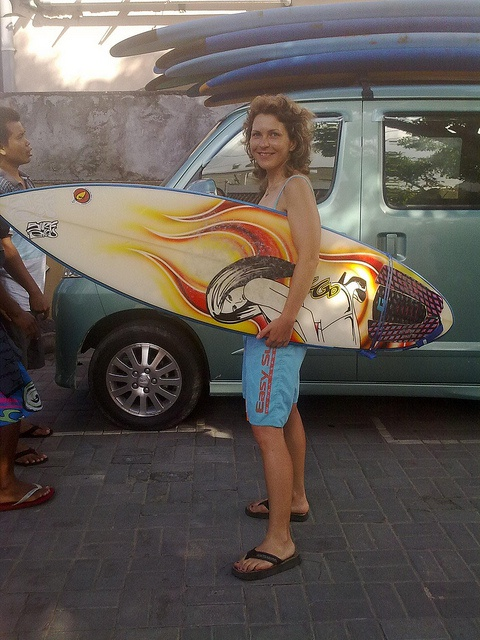Describe the objects in this image and their specific colors. I can see car in lightgray, black, gray, and darkgray tones, surfboard in lightgray, darkgray, tan, and black tones, people in lightgray, gray, brown, maroon, and black tones, people in lightgray, black, gray, and darkgray tones, and people in lightgray, black, maroon, gray, and navy tones in this image. 